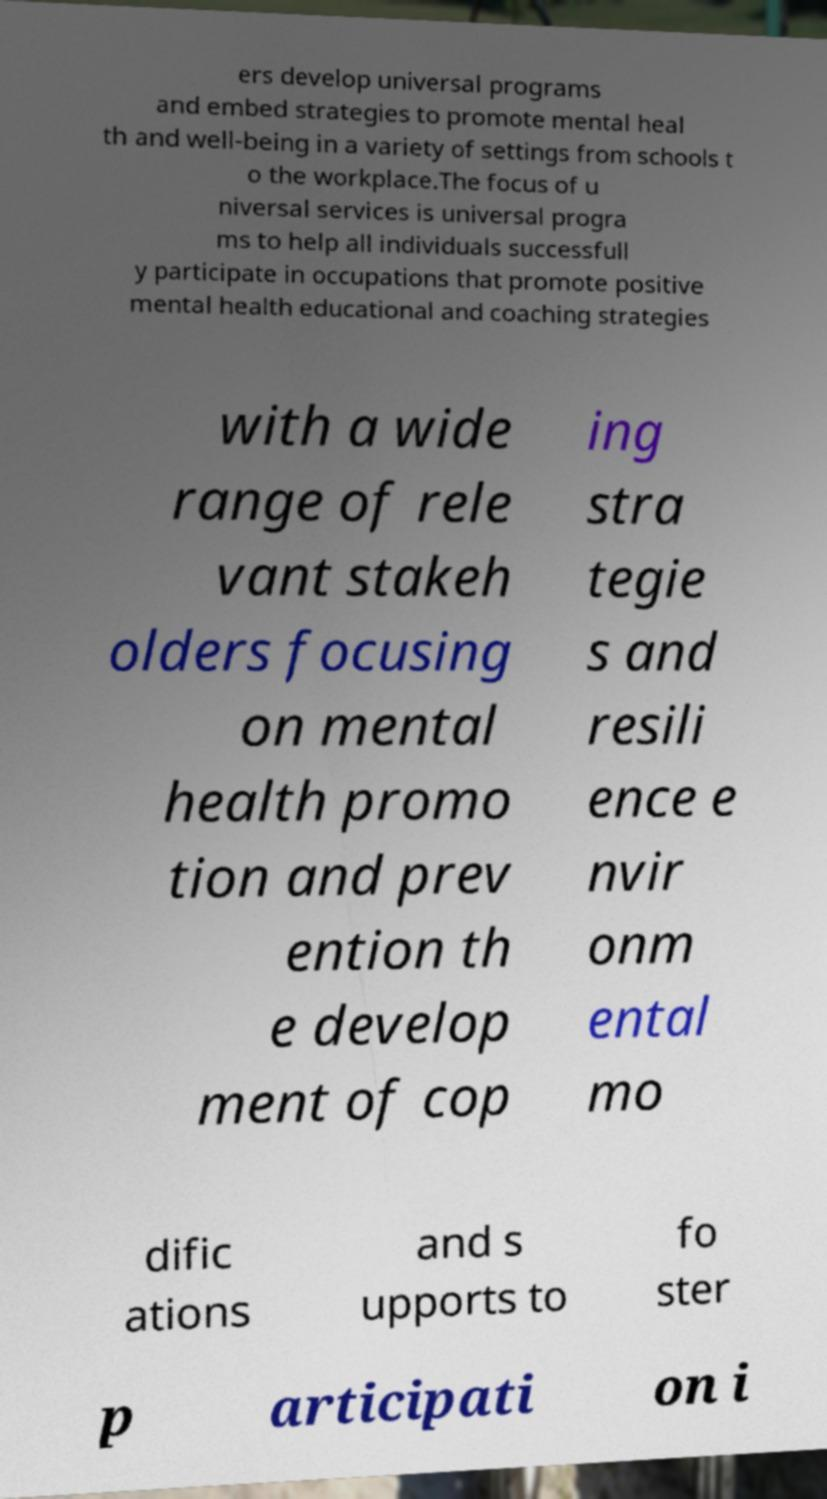What messages or text are displayed in this image? I need them in a readable, typed format. ers develop universal programs and embed strategies to promote mental heal th and well-being in a variety of settings from schools t o the workplace.The focus of u niversal services is universal progra ms to help all individuals successfull y participate in occupations that promote positive mental health educational and coaching strategies with a wide range of rele vant stakeh olders focusing on mental health promo tion and prev ention th e develop ment of cop ing stra tegie s and resili ence e nvir onm ental mo dific ations and s upports to fo ster p articipati on i 